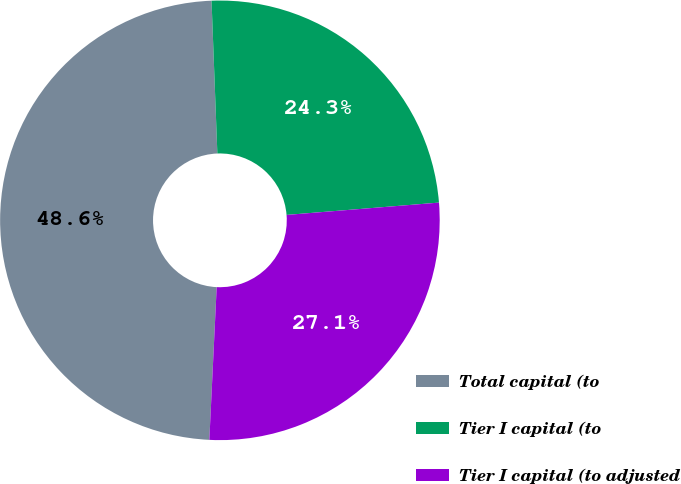Convert chart to OTSL. <chart><loc_0><loc_0><loc_500><loc_500><pie_chart><fcel>Total capital (to<fcel>Tier I capital (to<fcel>Tier I capital (to adjusted<nl><fcel>48.63%<fcel>24.32%<fcel>27.05%<nl></chart> 